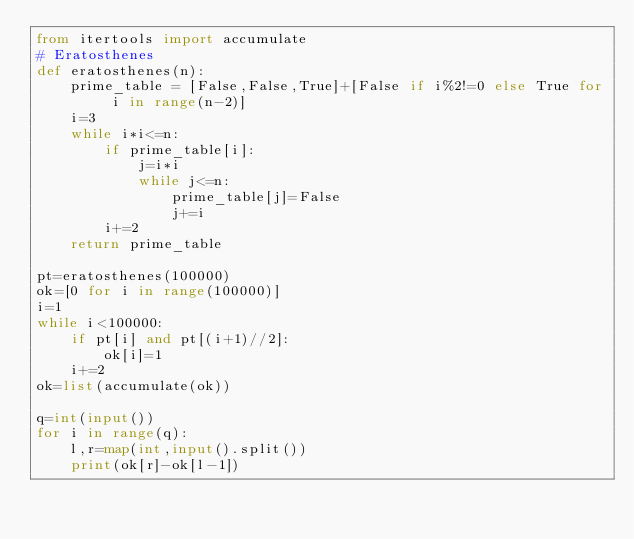<code> <loc_0><loc_0><loc_500><loc_500><_Python_>from itertools import accumulate
# Eratosthenes
def eratosthenes(n):
    prime_table = [False,False,True]+[False if i%2!=0 else True for i in range(n-2)]
    i=3
    while i*i<=n:
        if prime_table[i]:
            j=i*i
            while j<=n:
                prime_table[j]=False
                j+=i
        i+=2
    return prime_table

pt=eratosthenes(100000)
ok=[0 for i in range(100000)]
i=1
while i<100000:
    if pt[i] and pt[(i+1)//2]:
        ok[i]=1
    i+=2
ok=list(accumulate(ok))

q=int(input())
for i in range(q):
    l,r=map(int,input().split())
    print(ok[r]-ok[l-1])
    
</code> 